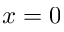<formula> <loc_0><loc_0><loc_500><loc_500>x = 0</formula> 